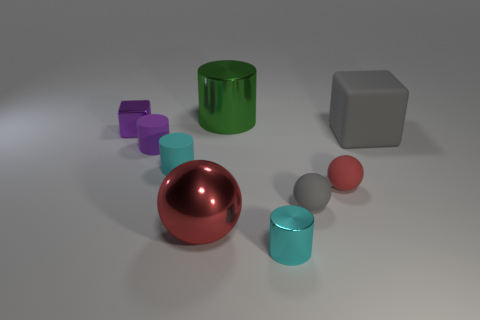Subtract 1 cylinders. How many cylinders are left? 3 Add 1 green cylinders. How many objects exist? 10 Subtract all spheres. How many objects are left? 6 Add 3 gray objects. How many gray objects are left? 5 Add 7 cubes. How many cubes exist? 9 Subtract 0 brown spheres. How many objects are left? 9 Subtract all matte blocks. Subtract all large metal balls. How many objects are left? 7 